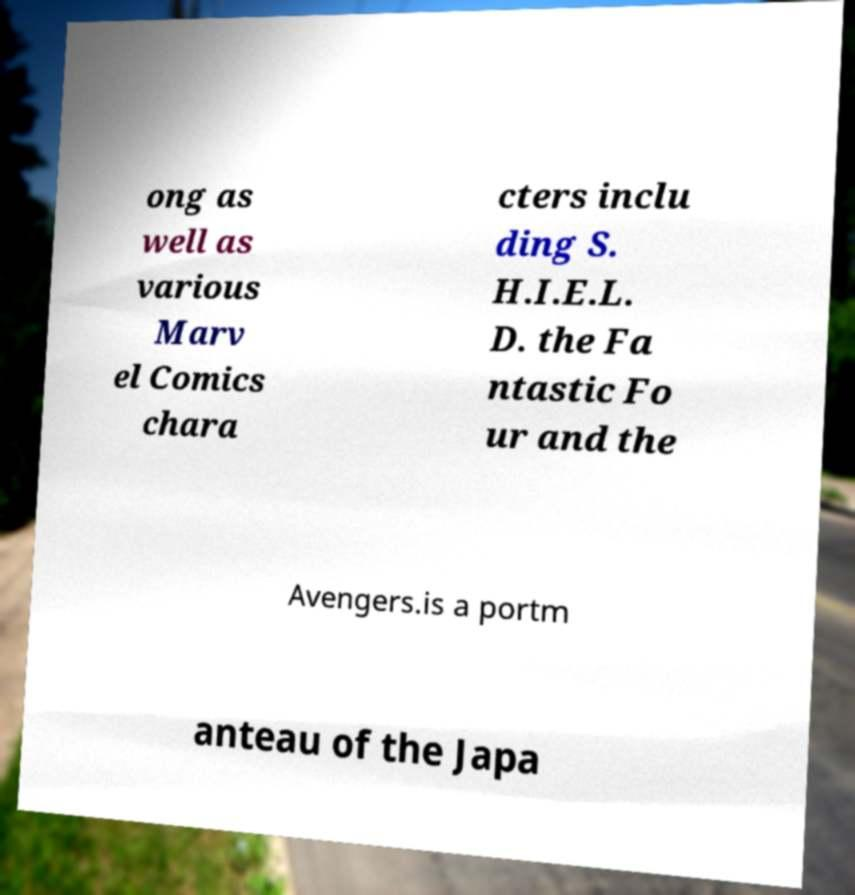Please read and relay the text visible in this image. What does it say? ong as well as various Marv el Comics chara cters inclu ding S. H.I.E.L. D. the Fa ntastic Fo ur and the Avengers.is a portm anteau of the Japa 